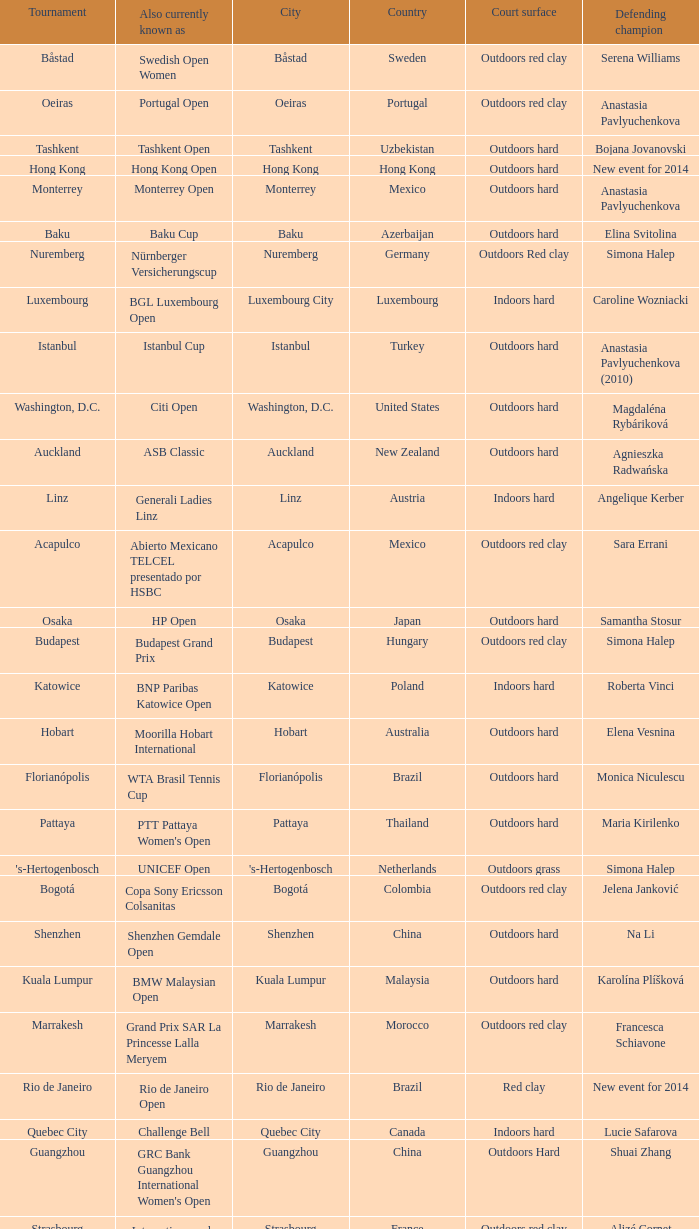How many tournaments are also currently known as the hp open? 1.0. 